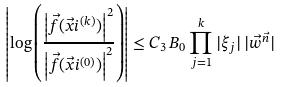Convert formula to latex. <formula><loc_0><loc_0><loc_500><loc_500>\left | \log \left ( \frac { \left | \vec { f } ( \vec { x } i ^ { ( k ) } ) \right | ^ { 2 } } { \left | \vec { f } ( \vec { x } i ^ { ( 0 ) } ) \right | ^ { 2 } } \right ) \right | \leq C _ { 3 } \, B _ { 0 } \prod _ { j = 1 } ^ { k } | \xi _ { j } | \, | \vec { w } ^ { \vec { n } } |</formula> 